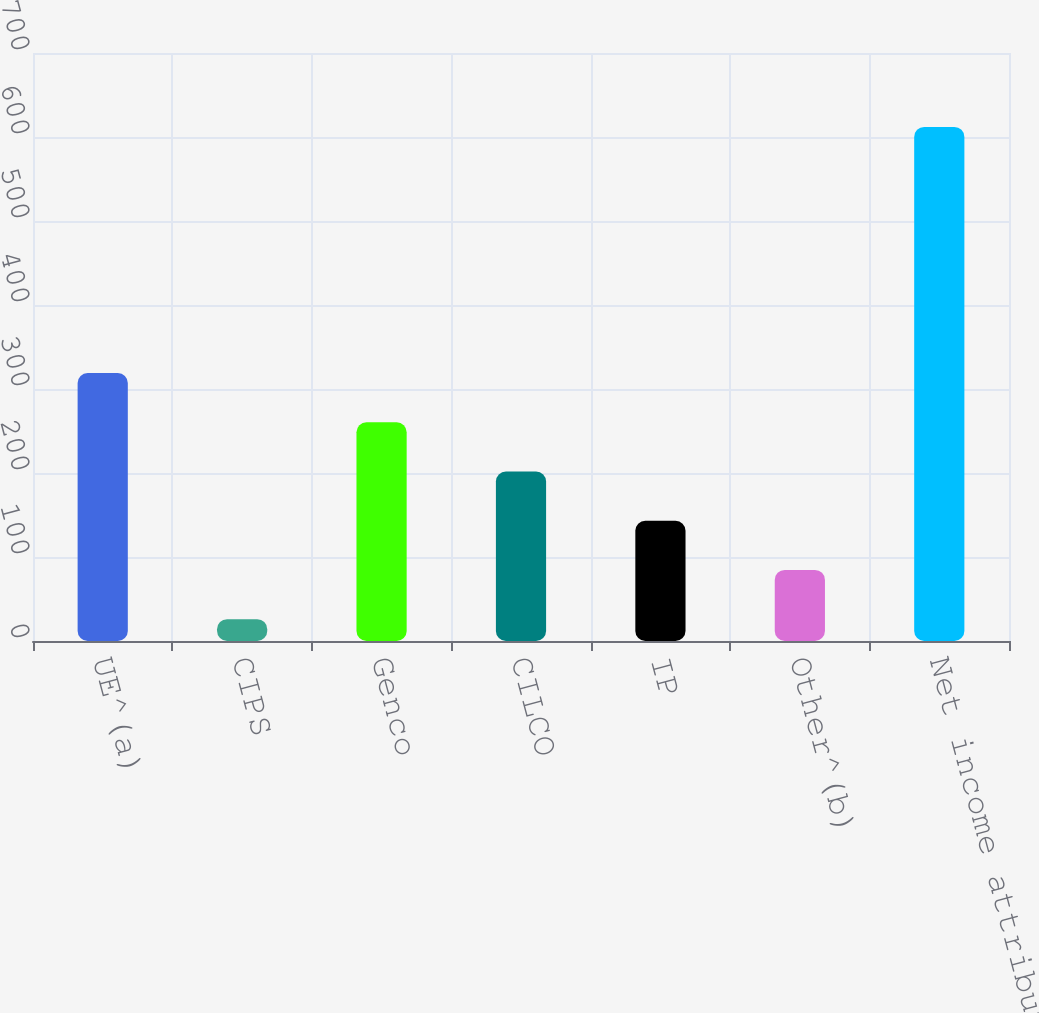<chart> <loc_0><loc_0><loc_500><loc_500><bar_chart><fcel>UE^(a)<fcel>CIPS<fcel>Genco<fcel>CILCO<fcel>IP<fcel>Other^(b)<fcel>Net income attributable to<nl><fcel>319<fcel>26<fcel>260.4<fcel>201.8<fcel>143.2<fcel>84.6<fcel>612<nl></chart> 